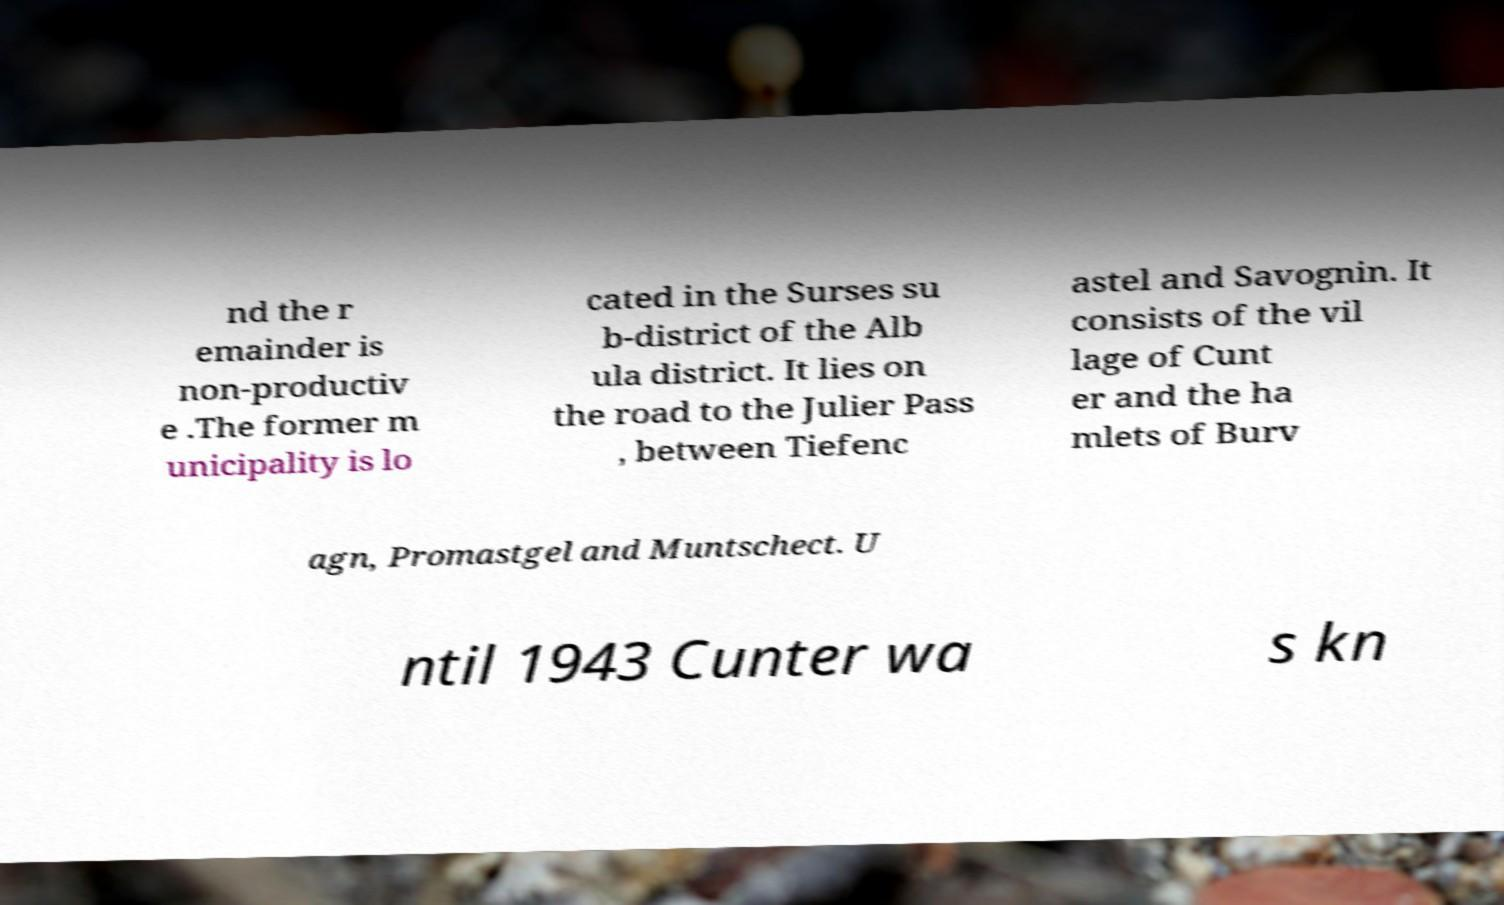Can you read and provide the text displayed in the image?This photo seems to have some interesting text. Can you extract and type it out for me? nd the r emainder is non-productiv e .The former m unicipality is lo cated in the Surses su b-district of the Alb ula district. It lies on the road to the Julier Pass , between Tiefenc astel and Savognin. It consists of the vil lage of Cunt er and the ha mlets of Burv agn, Promastgel and Muntschect. U ntil 1943 Cunter wa s kn 